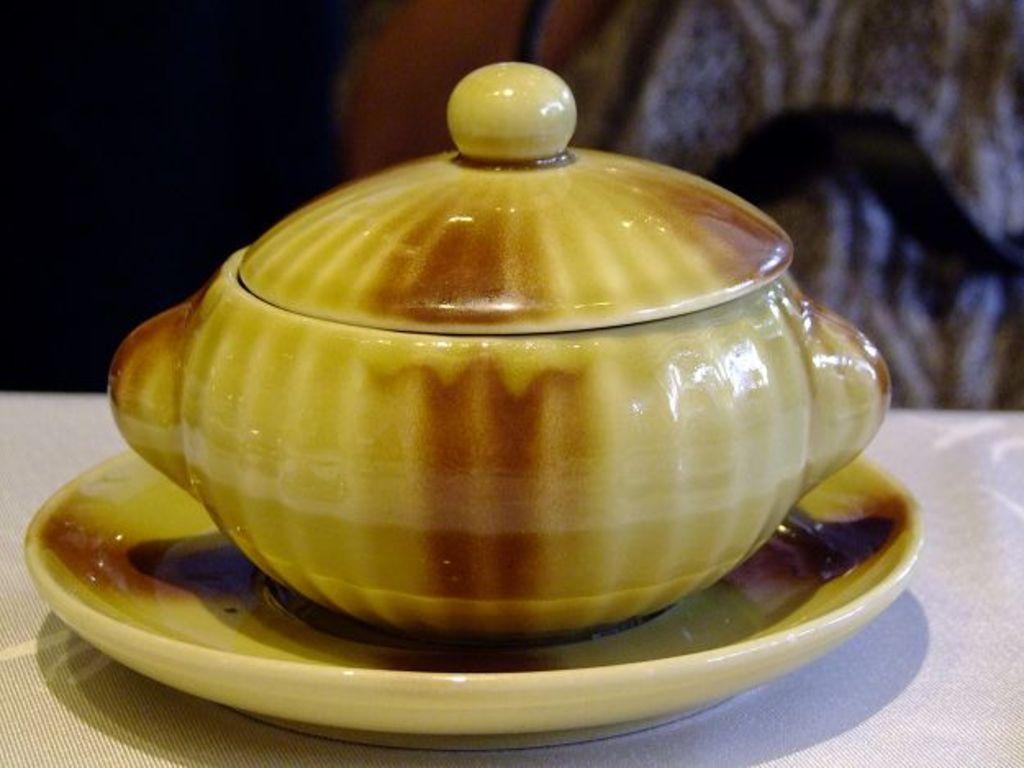Can you describe this image briefly? In the foreground of this image, on a saucer, there is a cup and on it there is a lid which is placed on a table like structure and the background image is not clear. 